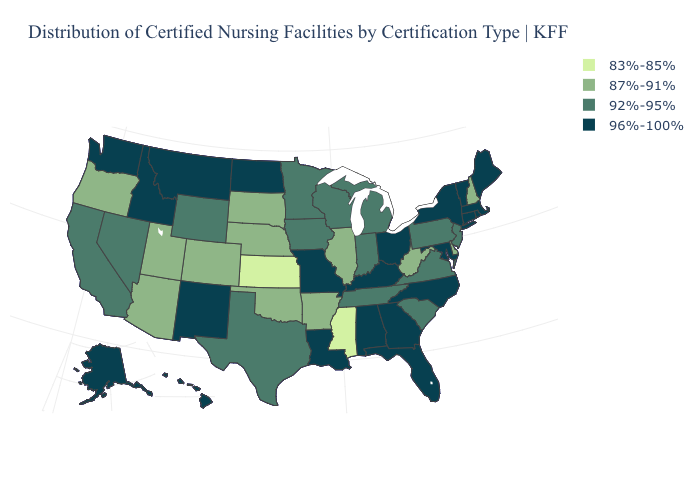Does California have a higher value than Colorado?
Write a very short answer. Yes. What is the value of Kansas?
Concise answer only. 83%-85%. Name the states that have a value in the range 96%-100%?
Give a very brief answer. Alabama, Alaska, Connecticut, Florida, Georgia, Hawaii, Idaho, Kentucky, Louisiana, Maine, Maryland, Massachusetts, Missouri, Montana, New Mexico, New York, North Carolina, North Dakota, Ohio, Rhode Island, Vermont, Washington. Name the states that have a value in the range 87%-91%?
Quick response, please. Arizona, Arkansas, Colorado, Delaware, Illinois, Nebraska, New Hampshire, Oklahoma, Oregon, South Dakota, Utah, West Virginia. Does Mississippi have the lowest value in the South?
Write a very short answer. Yes. What is the value of North Carolina?
Give a very brief answer. 96%-100%. What is the value of Georgia?
Be succinct. 96%-100%. What is the value of North Carolina?
Keep it brief. 96%-100%. What is the value of North Dakota?
Give a very brief answer. 96%-100%. Name the states that have a value in the range 96%-100%?
Quick response, please. Alabama, Alaska, Connecticut, Florida, Georgia, Hawaii, Idaho, Kentucky, Louisiana, Maine, Maryland, Massachusetts, Missouri, Montana, New Mexico, New York, North Carolina, North Dakota, Ohio, Rhode Island, Vermont, Washington. Among the states that border Florida , which have the highest value?
Be succinct. Alabama, Georgia. Name the states that have a value in the range 83%-85%?
Concise answer only. Kansas, Mississippi. What is the highest value in states that border Mississippi?
Answer briefly. 96%-100%. Which states have the lowest value in the USA?
Quick response, please. Kansas, Mississippi. Does the map have missing data?
Give a very brief answer. No. 